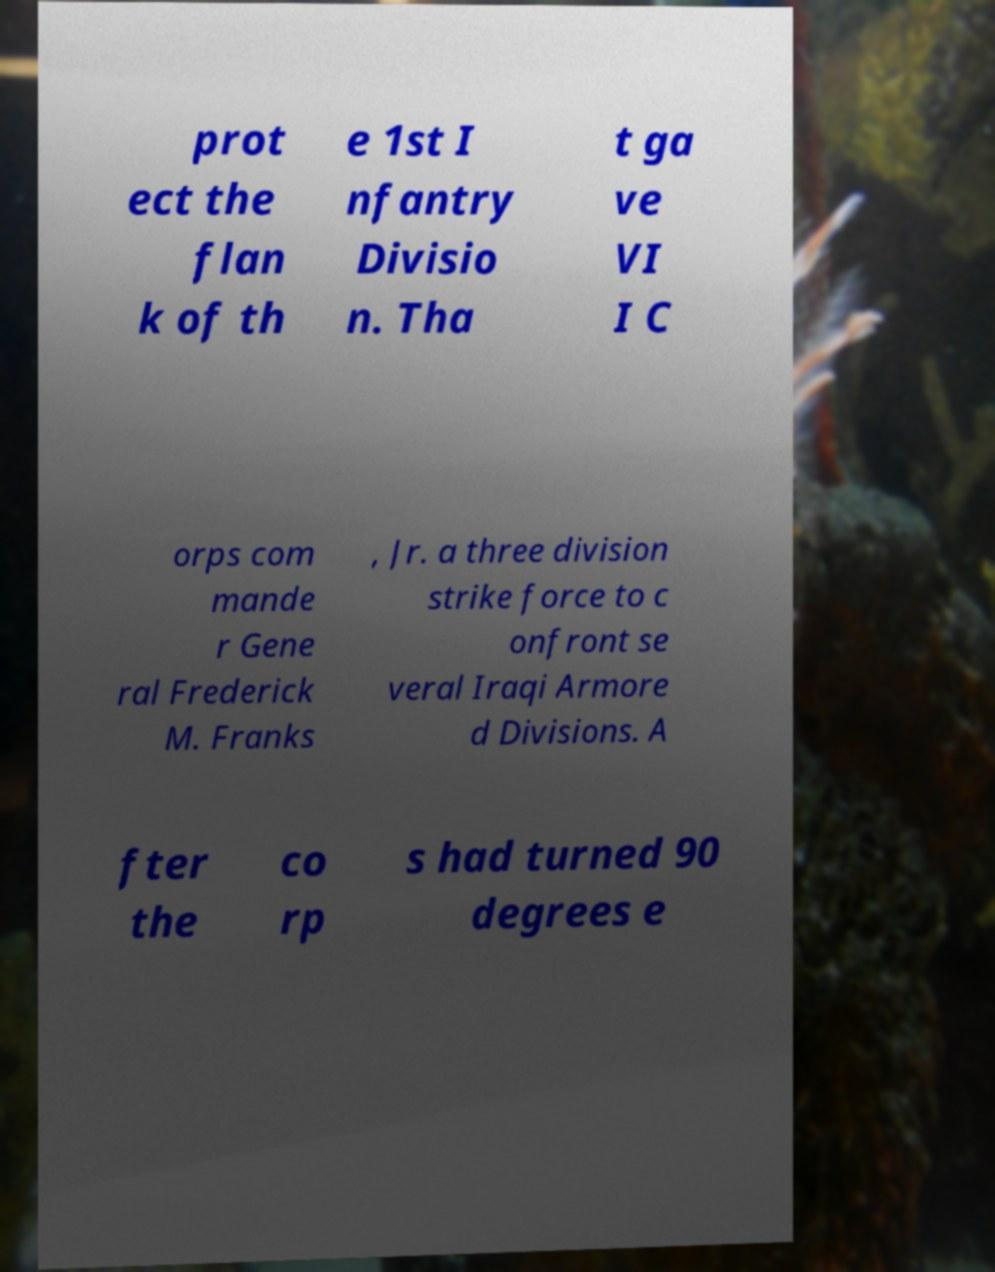There's text embedded in this image that I need extracted. Can you transcribe it verbatim? prot ect the flan k of th e 1st I nfantry Divisio n. Tha t ga ve VI I C orps com mande r Gene ral Frederick M. Franks , Jr. a three division strike force to c onfront se veral Iraqi Armore d Divisions. A fter the co rp s had turned 90 degrees e 